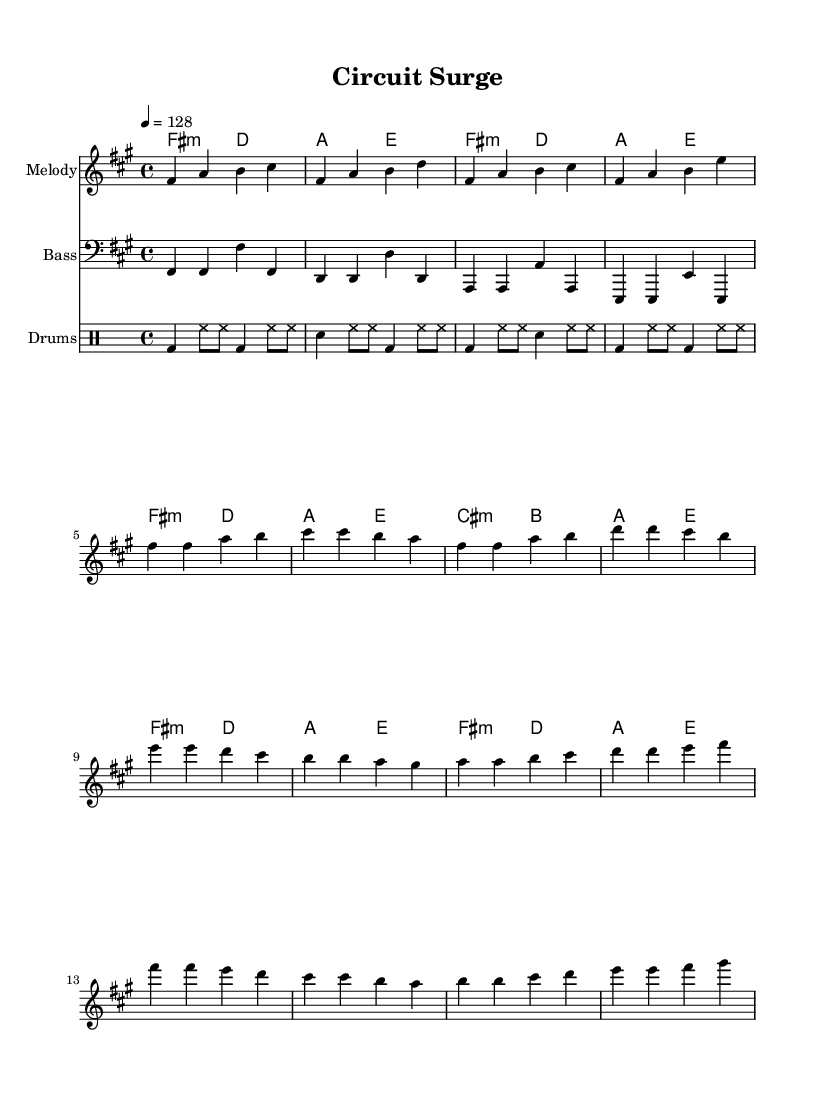What is the key signature of this music? The key signature in the first part of the sheet music indicates F sharp minor, which is represented by three sharps.
Answer: F sharp minor What is the time signature of this piece? The time signature shown in the music is four beats per measure, represented as 4/4.
Answer: 4/4 What is the tempo marking for this composition? The tempo marking reads "4 = 128," indicating that a quarter note is to be played at 128 beats per minute.
Answer: 128 How many measures are in the chorus section? By counting the measures labeled as "Chorus," there are four measures present as indicated by the grouping of notes.
Answer: 4 What is the predominant chord type used in the verses? The chords played in the verse section are primarily minor chords, specifically F sharp minor and D major.
Answer: Minor Which instrument is playing the bass line? The bass line is indicated by the clef "bass," which exclusively designates the instrument that will perform it.
Answer: Bass How do the drum patterns contribute to the K-Pop feel of the piece? The drum patterns feature a consistent bass drum on the downbeats and hi-hats playing eighth notes, providing an energetic and driving rhythm typical of K-Pop.
Answer: Energetic rhythm 